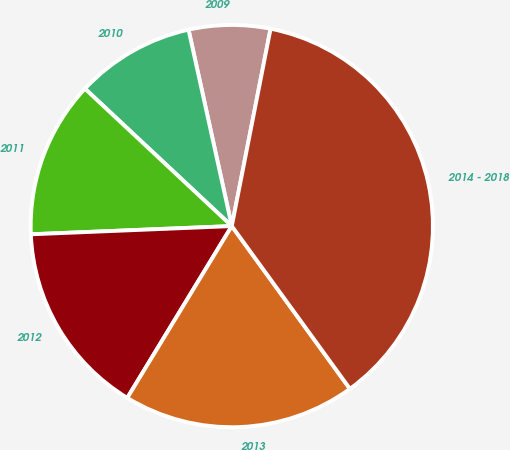Convert chart. <chart><loc_0><loc_0><loc_500><loc_500><pie_chart><fcel>2009<fcel>2010<fcel>2011<fcel>2012<fcel>2013<fcel>2014 - 2018<nl><fcel>6.54%<fcel>9.58%<fcel>12.62%<fcel>15.65%<fcel>18.69%<fcel>36.92%<nl></chart> 